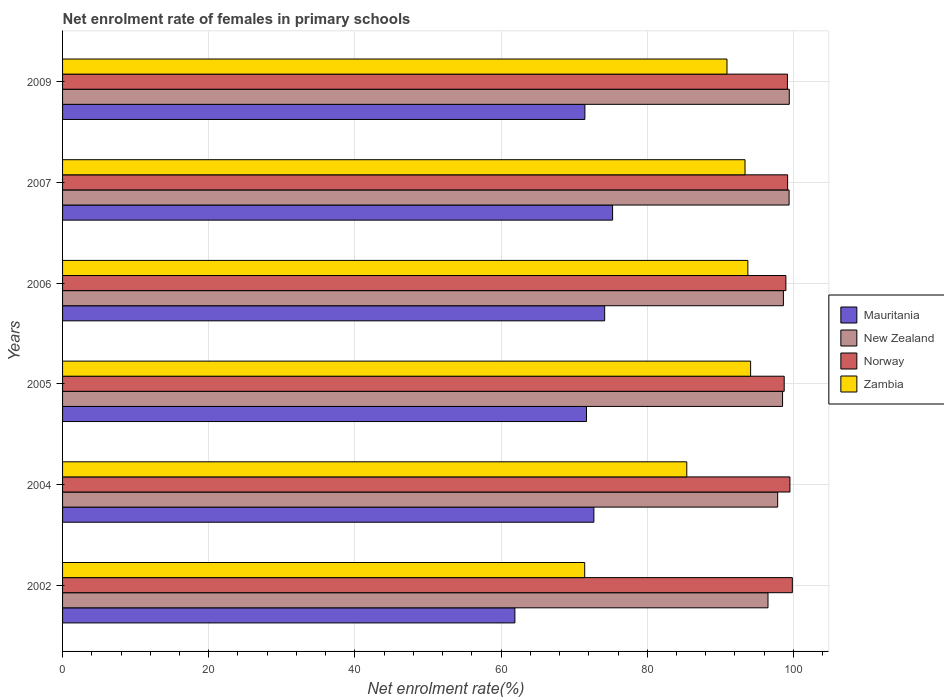How many different coloured bars are there?
Make the answer very short. 4. Are the number of bars per tick equal to the number of legend labels?
Ensure brevity in your answer.  Yes. Are the number of bars on each tick of the Y-axis equal?
Give a very brief answer. Yes. How many bars are there on the 4th tick from the top?
Keep it short and to the point. 4. How many bars are there on the 2nd tick from the bottom?
Provide a short and direct response. 4. What is the label of the 4th group of bars from the top?
Make the answer very short. 2005. What is the net enrolment rate of females in primary schools in Mauritania in 2007?
Provide a short and direct response. 75.26. Across all years, what is the maximum net enrolment rate of females in primary schools in New Zealand?
Offer a very short reply. 99.44. Across all years, what is the minimum net enrolment rate of females in primary schools in Mauritania?
Your answer should be very brief. 61.89. In which year was the net enrolment rate of females in primary schools in Norway minimum?
Make the answer very short. 2005. What is the total net enrolment rate of females in primary schools in Zambia in the graph?
Ensure brevity in your answer.  529.07. What is the difference between the net enrolment rate of females in primary schools in Norway in 2005 and that in 2006?
Make the answer very short. -0.23. What is the difference between the net enrolment rate of females in primary schools in Norway in 2005 and the net enrolment rate of females in primary schools in Mauritania in 2002?
Keep it short and to the point. 36.85. What is the average net enrolment rate of females in primary schools in Norway per year?
Your answer should be compact. 99.25. In the year 2002, what is the difference between the net enrolment rate of females in primary schools in Mauritania and net enrolment rate of females in primary schools in Norway?
Offer a terse response. -37.97. In how many years, is the net enrolment rate of females in primary schools in Zambia greater than 64 %?
Provide a succinct answer. 6. What is the ratio of the net enrolment rate of females in primary schools in New Zealand in 2002 to that in 2004?
Your answer should be very brief. 0.99. Is the net enrolment rate of females in primary schools in New Zealand in 2005 less than that in 2007?
Provide a succinct answer. Yes. What is the difference between the highest and the second highest net enrolment rate of females in primary schools in Norway?
Provide a short and direct response. 0.33. What is the difference between the highest and the lowest net enrolment rate of females in primary schools in New Zealand?
Ensure brevity in your answer.  2.91. Is the sum of the net enrolment rate of females in primary schools in New Zealand in 2004 and 2009 greater than the maximum net enrolment rate of females in primary schools in Mauritania across all years?
Your answer should be very brief. Yes. Is it the case that in every year, the sum of the net enrolment rate of females in primary schools in New Zealand and net enrolment rate of females in primary schools in Norway is greater than the sum of net enrolment rate of females in primary schools in Mauritania and net enrolment rate of females in primary schools in Zambia?
Your answer should be compact. No. What does the 4th bar from the top in 2009 represents?
Offer a very short reply. Mauritania. Is it the case that in every year, the sum of the net enrolment rate of females in primary schools in Mauritania and net enrolment rate of females in primary schools in New Zealand is greater than the net enrolment rate of females in primary schools in Norway?
Offer a terse response. Yes. How many bars are there?
Give a very brief answer. 24. Are all the bars in the graph horizontal?
Your answer should be compact. Yes. What is the difference between two consecutive major ticks on the X-axis?
Your response must be concise. 20. Are the values on the major ticks of X-axis written in scientific E-notation?
Make the answer very short. No. Does the graph contain any zero values?
Make the answer very short. No. Where does the legend appear in the graph?
Offer a very short reply. Center right. What is the title of the graph?
Give a very brief answer. Net enrolment rate of females in primary schools. What is the label or title of the X-axis?
Provide a succinct answer. Net enrolment rate(%). What is the Net enrolment rate(%) of Mauritania in 2002?
Provide a short and direct response. 61.89. What is the Net enrolment rate(%) of New Zealand in 2002?
Your answer should be compact. 96.52. What is the Net enrolment rate(%) of Norway in 2002?
Provide a succinct answer. 99.86. What is the Net enrolment rate(%) in Zambia in 2002?
Provide a short and direct response. 71.45. What is the Net enrolment rate(%) in Mauritania in 2004?
Provide a short and direct response. 72.7. What is the Net enrolment rate(%) of New Zealand in 2004?
Offer a terse response. 97.85. What is the Net enrolment rate(%) in Norway in 2004?
Ensure brevity in your answer.  99.52. What is the Net enrolment rate(%) of Zambia in 2004?
Your answer should be very brief. 85.41. What is the Net enrolment rate(%) in Mauritania in 2005?
Give a very brief answer. 71.69. What is the Net enrolment rate(%) in New Zealand in 2005?
Your answer should be very brief. 98.52. What is the Net enrolment rate(%) of Norway in 2005?
Offer a terse response. 98.74. What is the Net enrolment rate(%) of Zambia in 2005?
Your answer should be compact. 94.15. What is the Net enrolment rate(%) in Mauritania in 2006?
Your answer should be very brief. 74.18. What is the Net enrolment rate(%) in New Zealand in 2006?
Give a very brief answer. 98.63. What is the Net enrolment rate(%) in Norway in 2006?
Give a very brief answer. 98.97. What is the Net enrolment rate(%) in Zambia in 2006?
Keep it short and to the point. 93.77. What is the Net enrolment rate(%) in Mauritania in 2007?
Offer a very short reply. 75.26. What is the Net enrolment rate(%) in New Zealand in 2007?
Your answer should be compact. 99.41. What is the Net enrolment rate(%) in Norway in 2007?
Ensure brevity in your answer.  99.21. What is the Net enrolment rate(%) in Zambia in 2007?
Offer a terse response. 93.38. What is the Net enrolment rate(%) of Mauritania in 2009?
Your answer should be compact. 71.47. What is the Net enrolment rate(%) in New Zealand in 2009?
Offer a terse response. 99.44. What is the Net enrolment rate(%) of Norway in 2009?
Provide a short and direct response. 99.19. What is the Net enrolment rate(%) of Zambia in 2009?
Your answer should be compact. 90.91. Across all years, what is the maximum Net enrolment rate(%) in Mauritania?
Your answer should be compact. 75.26. Across all years, what is the maximum Net enrolment rate(%) in New Zealand?
Your answer should be compact. 99.44. Across all years, what is the maximum Net enrolment rate(%) of Norway?
Offer a very short reply. 99.86. Across all years, what is the maximum Net enrolment rate(%) in Zambia?
Your answer should be compact. 94.15. Across all years, what is the minimum Net enrolment rate(%) of Mauritania?
Make the answer very short. 61.89. Across all years, what is the minimum Net enrolment rate(%) in New Zealand?
Your answer should be compact. 96.52. Across all years, what is the minimum Net enrolment rate(%) of Norway?
Offer a very short reply. 98.74. Across all years, what is the minimum Net enrolment rate(%) of Zambia?
Your response must be concise. 71.45. What is the total Net enrolment rate(%) in Mauritania in the graph?
Offer a terse response. 427.19. What is the total Net enrolment rate(%) in New Zealand in the graph?
Offer a terse response. 590.38. What is the total Net enrolment rate(%) of Norway in the graph?
Keep it short and to the point. 595.49. What is the total Net enrolment rate(%) in Zambia in the graph?
Ensure brevity in your answer.  529.07. What is the difference between the Net enrolment rate(%) in Mauritania in 2002 and that in 2004?
Offer a terse response. -10.81. What is the difference between the Net enrolment rate(%) of New Zealand in 2002 and that in 2004?
Provide a short and direct response. -1.33. What is the difference between the Net enrolment rate(%) in Norway in 2002 and that in 2004?
Provide a short and direct response. 0.33. What is the difference between the Net enrolment rate(%) in Zambia in 2002 and that in 2004?
Provide a succinct answer. -13.97. What is the difference between the Net enrolment rate(%) of Mauritania in 2002 and that in 2005?
Ensure brevity in your answer.  -9.8. What is the difference between the Net enrolment rate(%) of New Zealand in 2002 and that in 2005?
Your response must be concise. -1.99. What is the difference between the Net enrolment rate(%) of Norway in 2002 and that in 2005?
Keep it short and to the point. 1.11. What is the difference between the Net enrolment rate(%) in Zambia in 2002 and that in 2005?
Make the answer very short. -22.7. What is the difference between the Net enrolment rate(%) in Mauritania in 2002 and that in 2006?
Your answer should be very brief. -12.28. What is the difference between the Net enrolment rate(%) in New Zealand in 2002 and that in 2006?
Ensure brevity in your answer.  -2.11. What is the difference between the Net enrolment rate(%) of Norway in 2002 and that in 2006?
Offer a terse response. 0.88. What is the difference between the Net enrolment rate(%) in Zambia in 2002 and that in 2006?
Your answer should be very brief. -22.32. What is the difference between the Net enrolment rate(%) in Mauritania in 2002 and that in 2007?
Offer a terse response. -13.37. What is the difference between the Net enrolment rate(%) in New Zealand in 2002 and that in 2007?
Give a very brief answer. -2.89. What is the difference between the Net enrolment rate(%) of Norway in 2002 and that in 2007?
Keep it short and to the point. 0.65. What is the difference between the Net enrolment rate(%) in Zambia in 2002 and that in 2007?
Your answer should be compact. -21.94. What is the difference between the Net enrolment rate(%) in Mauritania in 2002 and that in 2009?
Keep it short and to the point. -9.58. What is the difference between the Net enrolment rate(%) of New Zealand in 2002 and that in 2009?
Your answer should be compact. -2.91. What is the difference between the Net enrolment rate(%) of Norway in 2002 and that in 2009?
Your answer should be very brief. 0.67. What is the difference between the Net enrolment rate(%) of Zambia in 2002 and that in 2009?
Offer a terse response. -19.47. What is the difference between the Net enrolment rate(%) of Mauritania in 2004 and that in 2005?
Keep it short and to the point. 1.01. What is the difference between the Net enrolment rate(%) of New Zealand in 2004 and that in 2005?
Keep it short and to the point. -0.67. What is the difference between the Net enrolment rate(%) in Norway in 2004 and that in 2005?
Keep it short and to the point. 0.78. What is the difference between the Net enrolment rate(%) of Zambia in 2004 and that in 2005?
Your answer should be compact. -8.73. What is the difference between the Net enrolment rate(%) of Mauritania in 2004 and that in 2006?
Keep it short and to the point. -1.48. What is the difference between the Net enrolment rate(%) of New Zealand in 2004 and that in 2006?
Provide a short and direct response. -0.78. What is the difference between the Net enrolment rate(%) in Norway in 2004 and that in 2006?
Provide a succinct answer. 0.55. What is the difference between the Net enrolment rate(%) of Zambia in 2004 and that in 2006?
Your answer should be compact. -8.36. What is the difference between the Net enrolment rate(%) of Mauritania in 2004 and that in 2007?
Provide a succinct answer. -2.56. What is the difference between the Net enrolment rate(%) in New Zealand in 2004 and that in 2007?
Provide a short and direct response. -1.56. What is the difference between the Net enrolment rate(%) of Norway in 2004 and that in 2007?
Make the answer very short. 0.31. What is the difference between the Net enrolment rate(%) of Zambia in 2004 and that in 2007?
Your response must be concise. -7.97. What is the difference between the Net enrolment rate(%) of Mauritania in 2004 and that in 2009?
Provide a succinct answer. 1.23. What is the difference between the Net enrolment rate(%) in New Zealand in 2004 and that in 2009?
Make the answer very short. -1.59. What is the difference between the Net enrolment rate(%) of Norway in 2004 and that in 2009?
Provide a short and direct response. 0.34. What is the difference between the Net enrolment rate(%) of Zambia in 2004 and that in 2009?
Provide a succinct answer. -5.5. What is the difference between the Net enrolment rate(%) of Mauritania in 2005 and that in 2006?
Offer a terse response. -2.49. What is the difference between the Net enrolment rate(%) in New Zealand in 2005 and that in 2006?
Provide a succinct answer. -0.11. What is the difference between the Net enrolment rate(%) in Norway in 2005 and that in 2006?
Provide a succinct answer. -0.23. What is the difference between the Net enrolment rate(%) of Zambia in 2005 and that in 2006?
Your answer should be very brief. 0.38. What is the difference between the Net enrolment rate(%) of Mauritania in 2005 and that in 2007?
Your answer should be very brief. -3.57. What is the difference between the Net enrolment rate(%) in New Zealand in 2005 and that in 2007?
Provide a succinct answer. -0.89. What is the difference between the Net enrolment rate(%) in Norway in 2005 and that in 2007?
Provide a succinct answer. -0.47. What is the difference between the Net enrolment rate(%) of Zambia in 2005 and that in 2007?
Give a very brief answer. 0.77. What is the difference between the Net enrolment rate(%) in Mauritania in 2005 and that in 2009?
Your response must be concise. 0.22. What is the difference between the Net enrolment rate(%) of New Zealand in 2005 and that in 2009?
Make the answer very short. -0.92. What is the difference between the Net enrolment rate(%) of Norway in 2005 and that in 2009?
Keep it short and to the point. -0.44. What is the difference between the Net enrolment rate(%) of Zambia in 2005 and that in 2009?
Provide a succinct answer. 3.23. What is the difference between the Net enrolment rate(%) in Mauritania in 2006 and that in 2007?
Make the answer very short. -1.08. What is the difference between the Net enrolment rate(%) of New Zealand in 2006 and that in 2007?
Offer a terse response. -0.78. What is the difference between the Net enrolment rate(%) of Norway in 2006 and that in 2007?
Offer a terse response. -0.24. What is the difference between the Net enrolment rate(%) of Zambia in 2006 and that in 2007?
Ensure brevity in your answer.  0.39. What is the difference between the Net enrolment rate(%) in Mauritania in 2006 and that in 2009?
Provide a succinct answer. 2.71. What is the difference between the Net enrolment rate(%) of New Zealand in 2006 and that in 2009?
Make the answer very short. -0.81. What is the difference between the Net enrolment rate(%) in Norway in 2006 and that in 2009?
Offer a very short reply. -0.21. What is the difference between the Net enrolment rate(%) in Zambia in 2006 and that in 2009?
Your response must be concise. 2.86. What is the difference between the Net enrolment rate(%) of Mauritania in 2007 and that in 2009?
Make the answer very short. 3.79. What is the difference between the Net enrolment rate(%) of New Zealand in 2007 and that in 2009?
Make the answer very short. -0.03. What is the difference between the Net enrolment rate(%) of Norway in 2007 and that in 2009?
Provide a short and direct response. 0.02. What is the difference between the Net enrolment rate(%) in Zambia in 2007 and that in 2009?
Your answer should be very brief. 2.47. What is the difference between the Net enrolment rate(%) in Mauritania in 2002 and the Net enrolment rate(%) in New Zealand in 2004?
Give a very brief answer. -35.96. What is the difference between the Net enrolment rate(%) of Mauritania in 2002 and the Net enrolment rate(%) of Norway in 2004?
Your answer should be very brief. -37.63. What is the difference between the Net enrolment rate(%) in Mauritania in 2002 and the Net enrolment rate(%) in Zambia in 2004?
Your response must be concise. -23.52. What is the difference between the Net enrolment rate(%) of New Zealand in 2002 and the Net enrolment rate(%) of Norway in 2004?
Make the answer very short. -3. What is the difference between the Net enrolment rate(%) in New Zealand in 2002 and the Net enrolment rate(%) in Zambia in 2004?
Your answer should be compact. 11.11. What is the difference between the Net enrolment rate(%) in Norway in 2002 and the Net enrolment rate(%) in Zambia in 2004?
Make the answer very short. 14.45. What is the difference between the Net enrolment rate(%) in Mauritania in 2002 and the Net enrolment rate(%) in New Zealand in 2005?
Offer a very short reply. -36.63. What is the difference between the Net enrolment rate(%) in Mauritania in 2002 and the Net enrolment rate(%) in Norway in 2005?
Offer a very short reply. -36.85. What is the difference between the Net enrolment rate(%) in Mauritania in 2002 and the Net enrolment rate(%) in Zambia in 2005?
Offer a very short reply. -32.25. What is the difference between the Net enrolment rate(%) of New Zealand in 2002 and the Net enrolment rate(%) of Norway in 2005?
Give a very brief answer. -2.22. What is the difference between the Net enrolment rate(%) in New Zealand in 2002 and the Net enrolment rate(%) in Zambia in 2005?
Your answer should be compact. 2.38. What is the difference between the Net enrolment rate(%) of Norway in 2002 and the Net enrolment rate(%) of Zambia in 2005?
Offer a very short reply. 5.71. What is the difference between the Net enrolment rate(%) of Mauritania in 2002 and the Net enrolment rate(%) of New Zealand in 2006?
Make the answer very short. -36.74. What is the difference between the Net enrolment rate(%) of Mauritania in 2002 and the Net enrolment rate(%) of Norway in 2006?
Keep it short and to the point. -37.08. What is the difference between the Net enrolment rate(%) in Mauritania in 2002 and the Net enrolment rate(%) in Zambia in 2006?
Provide a short and direct response. -31.88. What is the difference between the Net enrolment rate(%) of New Zealand in 2002 and the Net enrolment rate(%) of Norway in 2006?
Make the answer very short. -2.45. What is the difference between the Net enrolment rate(%) in New Zealand in 2002 and the Net enrolment rate(%) in Zambia in 2006?
Your response must be concise. 2.75. What is the difference between the Net enrolment rate(%) of Norway in 2002 and the Net enrolment rate(%) of Zambia in 2006?
Keep it short and to the point. 6.09. What is the difference between the Net enrolment rate(%) of Mauritania in 2002 and the Net enrolment rate(%) of New Zealand in 2007?
Offer a very short reply. -37.52. What is the difference between the Net enrolment rate(%) of Mauritania in 2002 and the Net enrolment rate(%) of Norway in 2007?
Provide a succinct answer. -37.32. What is the difference between the Net enrolment rate(%) of Mauritania in 2002 and the Net enrolment rate(%) of Zambia in 2007?
Provide a succinct answer. -31.49. What is the difference between the Net enrolment rate(%) in New Zealand in 2002 and the Net enrolment rate(%) in Norway in 2007?
Your response must be concise. -2.69. What is the difference between the Net enrolment rate(%) in New Zealand in 2002 and the Net enrolment rate(%) in Zambia in 2007?
Offer a terse response. 3.14. What is the difference between the Net enrolment rate(%) of Norway in 2002 and the Net enrolment rate(%) of Zambia in 2007?
Keep it short and to the point. 6.48. What is the difference between the Net enrolment rate(%) of Mauritania in 2002 and the Net enrolment rate(%) of New Zealand in 2009?
Ensure brevity in your answer.  -37.55. What is the difference between the Net enrolment rate(%) in Mauritania in 2002 and the Net enrolment rate(%) in Norway in 2009?
Your answer should be compact. -37.3. What is the difference between the Net enrolment rate(%) in Mauritania in 2002 and the Net enrolment rate(%) in Zambia in 2009?
Your answer should be very brief. -29.02. What is the difference between the Net enrolment rate(%) in New Zealand in 2002 and the Net enrolment rate(%) in Norway in 2009?
Your response must be concise. -2.66. What is the difference between the Net enrolment rate(%) of New Zealand in 2002 and the Net enrolment rate(%) of Zambia in 2009?
Your response must be concise. 5.61. What is the difference between the Net enrolment rate(%) of Norway in 2002 and the Net enrolment rate(%) of Zambia in 2009?
Your answer should be very brief. 8.94. What is the difference between the Net enrolment rate(%) of Mauritania in 2004 and the Net enrolment rate(%) of New Zealand in 2005?
Offer a terse response. -25.82. What is the difference between the Net enrolment rate(%) in Mauritania in 2004 and the Net enrolment rate(%) in Norway in 2005?
Your answer should be very brief. -26.04. What is the difference between the Net enrolment rate(%) in Mauritania in 2004 and the Net enrolment rate(%) in Zambia in 2005?
Ensure brevity in your answer.  -21.45. What is the difference between the Net enrolment rate(%) of New Zealand in 2004 and the Net enrolment rate(%) of Norway in 2005?
Your response must be concise. -0.89. What is the difference between the Net enrolment rate(%) of New Zealand in 2004 and the Net enrolment rate(%) of Zambia in 2005?
Your answer should be very brief. 3.7. What is the difference between the Net enrolment rate(%) of Norway in 2004 and the Net enrolment rate(%) of Zambia in 2005?
Offer a terse response. 5.38. What is the difference between the Net enrolment rate(%) in Mauritania in 2004 and the Net enrolment rate(%) in New Zealand in 2006?
Ensure brevity in your answer.  -25.93. What is the difference between the Net enrolment rate(%) of Mauritania in 2004 and the Net enrolment rate(%) of Norway in 2006?
Offer a very short reply. -26.27. What is the difference between the Net enrolment rate(%) of Mauritania in 2004 and the Net enrolment rate(%) of Zambia in 2006?
Your answer should be very brief. -21.07. What is the difference between the Net enrolment rate(%) of New Zealand in 2004 and the Net enrolment rate(%) of Norway in 2006?
Keep it short and to the point. -1.12. What is the difference between the Net enrolment rate(%) of New Zealand in 2004 and the Net enrolment rate(%) of Zambia in 2006?
Offer a terse response. 4.08. What is the difference between the Net enrolment rate(%) in Norway in 2004 and the Net enrolment rate(%) in Zambia in 2006?
Your answer should be compact. 5.75. What is the difference between the Net enrolment rate(%) in Mauritania in 2004 and the Net enrolment rate(%) in New Zealand in 2007?
Make the answer very short. -26.71. What is the difference between the Net enrolment rate(%) of Mauritania in 2004 and the Net enrolment rate(%) of Norway in 2007?
Offer a very short reply. -26.51. What is the difference between the Net enrolment rate(%) in Mauritania in 2004 and the Net enrolment rate(%) in Zambia in 2007?
Keep it short and to the point. -20.68. What is the difference between the Net enrolment rate(%) in New Zealand in 2004 and the Net enrolment rate(%) in Norway in 2007?
Provide a short and direct response. -1.36. What is the difference between the Net enrolment rate(%) of New Zealand in 2004 and the Net enrolment rate(%) of Zambia in 2007?
Your answer should be very brief. 4.47. What is the difference between the Net enrolment rate(%) of Norway in 2004 and the Net enrolment rate(%) of Zambia in 2007?
Your answer should be compact. 6.14. What is the difference between the Net enrolment rate(%) in Mauritania in 2004 and the Net enrolment rate(%) in New Zealand in 2009?
Offer a terse response. -26.74. What is the difference between the Net enrolment rate(%) in Mauritania in 2004 and the Net enrolment rate(%) in Norway in 2009?
Provide a succinct answer. -26.49. What is the difference between the Net enrolment rate(%) of Mauritania in 2004 and the Net enrolment rate(%) of Zambia in 2009?
Ensure brevity in your answer.  -18.21. What is the difference between the Net enrolment rate(%) of New Zealand in 2004 and the Net enrolment rate(%) of Norway in 2009?
Offer a very short reply. -1.34. What is the difference between the Net enrolment rate(%) of New Zealand in 2004 and the Net enrolment rate(%) of Zambia in 2009?
Give a very brief answer. 6.94. What is the difference between the Net enrolment rate(%) in Norway in 2004 and the Net enrolment rate(%) in Zambia in 2009?
Make the answer very short. 8.61. What is the difference between the Net enrolment rate(%) in Mauritania in 2005 and the Net enrolment rate(%) in New Zealand in 2006?
Your answer should be very brief. -26.94. What is the difference between the Net enrolment rate(%) in Mauritania in 2005 and the Net enrolment rate(%) in Norway in 2006?
Offer a terse response. -27.28. What is the difference between the Net enrolment rate(%) in Mauritania in 2005 and the Net enrolment rate(%) in Zambia in 2006?
Provide a short and direct response. -22.08. What is the difference between the Net enrolment rate(%) of New Zealand in 2005 and the Net enrolment rate(%) of Norway in 2006?
Provide a succinct answer. -0.45. What is the difference between the Net enrolment rate(%) of New Zealand in 2005 and the Net enrolment rate(%) of Zambia in 2006?
Offer a terse response. 4.75. What is the difference between the Net enrolment rate(%) of Norway in 2005 and the Net enrolment rate(%) of Zambia in 2006?
Offer a very short reply. 4.97. What is the difference between the Net enrolment rate(%) in Mauritania in 2005 and the Net enrolment rate(%) in New Zealand in 2007?
Give a very brief answer. -27.72. What is the difference between the Net enrolment rate(%) of Mauritania in 2005 and the Net enrolment rate(%) of Norway in 2007?
Give a very brief answer. -27.52. What is the difference between the Net enrolment rate(%) of Mauritania in 2005 and the Net enrolment rate(%) of Zambia in 2007?
Offer a terse response. -21.69. What is the difference between the Net enrolment rate(%) in New Zealand in 2005 and the Net enrolment rate(%) in Norway in 2007?
Your response must be concise. -0.69. What is the difference between the Net enrolment rate(%) in New Zealand in 2005 and the Net enrolment rate(%) in Zambia in 2007?
Provide a succinct answer. 5.14. What is the difference between the Net enrolment rate(%) of Norway in 2005 and the Net enrolment rate(%) of Zambia in 2007?
Your response must be concise. 5.36. What is the difference between the Net enrolment rate(%) of Mauritania in 2005 and the Net enrolment rate(%) of New Zealand in 2009?
Keep it short and to the point. -27.75. What is the difference between the Net enrolment rate(%) of Mauritania in 2005 and the Net enrolment rate(%) of Norway in 2009?
Offer a very short reply. -27.5. What is the difference between the Net enrolment rate(%) in Mauritania in 2005 and the Net enrolment rate(%) in Zambia in 2009?
Ensure brevity in your answer.  -19.22. What is the difference between the Net enrolment rate(%) of New Zealand in 2005 and the Net enrolment rate(%) of Norway in 2009?
Give a very brief answer. -0.67. What is the difference between the Net enrolment rate(%) of New Zealand in 2005 and the Net enrolment rate(%) of Zambia in 2009?
Your response must be concise. 7.61. What is the difference between the Net enrolment rate(%) of Norway in 2005 and the Net enrolment rate(%) of Zambia in 2009?
Keep it short and to the point. 7.83. What is the difference between the Net enrolment rate(%) of Mauritania in 2006 and the Net enrolment rate(%) of New Zealand in 2007?
Ensure brevity in your answer.  -25.24. What is the difference between the Net enrolment rate(%) in Mauritania in 2006 and the Net enrolment rate(%) in Norway in 2007?
Ensure brevity in your answer.  -25.03. What is the difference between the Net enrolment rate(%) in Mauritania in 2006 and the Net enrolment rate(%) in Zambia in 2007?
Give a very brief answer. -19.2. What is the difference between the Net enrolment rate(%) of New Zealand in 2006 and the Net enrolment rate(%) of Norway in 2007?
Offer a terse response. -0.58. What is the difference between the Net enrolment rate(%) in New Zealand in 2006 and the Net enrolment rate(%) in Zambia in 2007?
Offer a terse response. 5.25. What is the difference between the Net enrolment rate(%) in Norway in 2006 and the Net enrolment rate(%) in Zambia in 2007?
Keep it short and to the point. 5.59. What is the difference between the Net enrolment rate(%) in Mauritania in 2006 and the Net enrolment rate(%) in New Zealand in 2009?
Provide a short and direct response. -25.26. What is the difference between the Net enrolment rate(%) of Mauritania in 2006 and the Net enrolment rate(%) of Norway in 2009?
Ensure brevity in your answer.  -25.01. What is the difference between the Net enrolment rate(%) of Mauritania in 2006 and the Net enrolment rate(%) of Zambia in 2009?
Make the answer very short. -16.74. What is the difference between the Net enrolment rate(%) of New Zealand in 2006 and the Net enrolment rate(%) of Norway in 2009?
Provide a succinct answer. -0.55. What is the difference between the Net enrolment rate(%) of New Zealand in 2006 and the Net enrolment rate(%) of Zambia in 2009?
Ensure brevity in your answer.  7.72. What is the difference between the Net enrolment rate(%) in Norway in 2006 and the Net enrolment rate(%) in Zambia in 2009?
Your response must be concise. 8.06. What is the difference between the Net enrolment rate(%) in Mauritania in 2007 and the Net enrolment rate(%) in New Zealand in 2009?
Provide a succinct answer. -24.18. What is the difference between the Net enrolment rate(%) in Mauritania in 2007 and the Net enrolment rate(%) in Norway in 2009?
Offer a terse response. -23.93. What is the difference between the Net enrolment rate(%) in Mauritania in 2007 and the Net enrolment rate(%) in Zambia in 2009?
Offer a terse response. -15.65. What is the difference between the Net enrolment rate(%) of New Zealand in 2007 and the Net enrolment rate(%) of Norway in 2009?
Your response must be concise. 0.23. What is the difference between the Net enrolment rate(%) of New Zealand in 2007 and the Net enrolment rate(%) of Zambia in 2009?
Provide a short and direct response. 8.5. What is the difference between the Net enrolment rate(%) in Norway in 2007 and the Net enrolment rate(%) in Zambia in 2009?
Make the answer very short. 8.3. What is the average Net enrolment rate(%) of Mauritania per year?
Your answer should be very brief. 71.2. What is the average Net enrolment rate(%) of New Zealand per year?
Give a very brief answer. 98.4. What is the average Net enrolment rate(%) of Norway per year?
Provide a short and direct response. 99.25. What is the average Net enrolment rate(%) of Zambia per year?
Your answer should be compact. 88.18. In the year 2002, what is the difference between the Net enrolment rate(%) in Mauritania and Net enrolment rate(%) in New Zealand?
Your answer should be compact. -34.63. In the year 2002, what is the difference between the Net enrolment rate(%) of Mauritania and Net enrolment rate(%) of Norway?
Offer a very short reply. -37.97. In the year 2002, what is the difference between the Net enrolment rate(%) of Mauritania and Net enrolment rate(%) of Zambia?
Your response must be concise. -9.55. In the year 2002, what is the difference between the Net enrolment rate(%) in New Zealand and Net enrolment rate(%) in Norway?
Provide a short and direct response. -3.33. In the year 2002, what is the difference between the Net enrolment rate(%) of New Zealand and Net enrolment rate(%) of Zambia?
Offer a terse response. 25.08. In the year 2002, what is the difference between the Net enrolment rate(%) of Norway and Net enrolment rate(%) of Zambia?
Your response must be concise. 28.41. In the year 2004, what is the difference between the Net enrolment rate(%) in Mauritania and Net enrolment rate(%) in New Zealand?
Offer a terse response. -25.15. In the year 2004, what is the difference between the Net enrolment rate(%) in Mauritania and Net enrolment rate(%) in Norway?
Give a very brief answer. -26.83. In the year 2004, what is the difference between the Net enrolment rate(%) of Mauritania and Net enrolment rate(%) of Zambia?
Make the answer very short. -12.71. In the year 2004, what is the difference between the Net enrolment rate(%) of New Zealand and Net enrolment rate(%) of Norway?
Offer a terse response. -1.67. In the year 2004, what is the difference between the Net enrolment rate(%) of New Zealand and Net enrolment rate(%) of Zambia?
Your response must be concise. 12.44. In the year 2004, what is the difference between the Net enrolment rate(%) of Norway and Net enrolment rate(%) of Zambia?
Provide a succinct answer. 14.11. In the year 2005, what is the difference between the Net enrolment rate(%) of Mauritania and Net enrolment rate(%) of New Zealand?
Your answer should be compact. -26.83. In the year 2005, what is the difference between the Net enrolment rate(%) of Mauritania and Net enrolment rate(%) of Norway?
Provide a short and direct response. -27.05. In the year 2005, what is the difference between the Net enrolment rate(%) in Mauritania and Net enrolment rate(%) in Zambia?
Your answer should be very brief. -22.46. In the year 2005, what is the difference between the Net enrolment rate(%) in New Zealand and Net enrolment rate(%) in Norway?
Make the answer very short. -0.22. In the year 2005, what is the difference between the Net enrolment rate(%) of New Zealand and Net enrolment rate(%) of Zambia?
Provide a succinct answer. 4.37. In the year 2005, what is the difference between the Net enrolment rate(%) of Norway and Net enrolment rate(%) of Zambia?
Offer a terse response. 4.6. In the year 2006, what is the difference between the Net enrolment rate(%) in Mauritania and Net enrolment rate(%) in New Zealand?
Provide a succinct answer. -24.46. In the year 2006, what is the difference between the Net enrolment rate(%) of Mauritania and Net enrolment rate(%) of Norway?
Your answer should be very brief. -24.8. In the year 2006, what is the difference between the Net enrolment rate(%) of Mauritania and Net enrolment rate(%) of Zambia?
Offer a very short reply. -19.59. In the year 2006, what is the difference between the Net enrolment rate(%) in New Zealand and Net enrolment rate(%) in Norway?
Make the answer very short. -0.34. In the year 2006, what is the difference between the Net enrolment rate(%) of New Zealand and Net enrolment rate(%) of Zambia?
Your answer should be very brief. 4.86. In the year 2006, what is the difference between the Net enrolment rate(%) in Norway and Net enrolment rate(%) in Zambia?
Offer a very short reply. 5.2. In the year 2007, what is the difference between the Net enrolment rate(%) in Mauritania and Net enrolment rate(%) in New Zealand?
Offer a terse response. -24.15. In the year 2007, what is the difference between the Net enrolment rate(%) of Mauritania and Net enrolment rate(%) of Norway?
Offer a very short reply. -23.95. In the year 2007, what is the difference between the Net enrolment rate(%) of Mauritania and Net enrolment rate(%) of Zambia?
Offer a very short reply. -18.12. In the year 2007, what is the difference between the Net enrolment rate(%) of New Zealand and Net enrolment rate(%) of Norway?
Offer a very short reply. 0.2. In the year 2007, what is the difference between the Net enrolment rate(%) of New Zealand and Net enrolment rate(%) of Zambia?
Provide a succinct answer. 6.03. In the year 2007, what is the difference between the Net enrolment rate(%) in Norway and Net enrolment rate(%) in Zambia?
Your answer should be compact. 5.83. In the year 2009, what is the difference between the Net enrolment rate(%) in Mauritania and Net enrolment rate(%) in New Zealand?
Offer a very short reply. -27.97. In the year 2009, what is the difference between the Net enrolment rate(%) of Mauritania and Net enrolment rate(%) of Norway?
Provide a succinct answer. -27.72. In the year 2009, what is the difference between the Net enrolment rate(%) of Mauritania and Net enrolment rate(%) of Zambia?
Ensure brevity in your answer.  -19.44. In the year 2009, what is the difference between the Net enrolment rate(%) in New Zealand and Net enrolment rate(%) in Norway?
Offer a very short reply. 0.25. In the year 2009, what is the difference between the Net enrolment rate(%) in New Zealand and Net enrolment rate(%) in Zambia?
Your answer should be very brief. 8.52. In the year 2009, what is the difference between the Net enrolment rate(%) of Norway and Net enrolment rate(%) of Zambia?
Your answer should be very brief. 8.27. What is the ratio of the Net enrolment rate(%) in Mauritania in 2002 to that in 2004?
Ensure brevity in your answer.  0.85. What is the ratio of the Net enrolment rate(%) of New Zealand in 2002 to that in 2004?
Your answer should be compact. 0.99. What is the ratio of the Net enrolment rate(%) in Norway in 2002 to that in 2004?
Provide a succinct answer. 1. What is the ratio of the Net enrolment rate(%) in Zambia in 2002 to that in 2004?
Your response must be concise. 0.84. What is the ratio of the Net enrolment rate(%) of Mauritania in 2002 to that in 2005?
Ensure brevity in your answer.  0.86. What is the ratio of the Net enrolment rate(%) of New Zealand in 2002 to that in 2005?
Ensure brevity in your answer.  0.98. What is the ratio of the Net enrolment rate(%) of Norway in 2002 to that in 2005?
Your answer should be very brief. 1.01. What is the ratio of the Net enrolment rate(%) of Zambia in 2002 to that in 2005?
Give a very brief answer. 0.76. What is the ratio of the Net enrolment rate(%) in Mauritania in 2002 to that in 2006?
Provide a short and direct response. 0.83. What is the ratio of the Net enrolment rate(%) of New Zealand in 2002 to that in 2006?
Provide a short and direct response. 0.98. What is the ratio of the Net enrolment rate(%) in Norway in 2002 to that in 2006?
Make the answer very short. 1.01. What is the ratio of the Net enrolment rate(%) of Zambia in 2002 to that in 2006?
Ensure brevity in your answer.  0.76. What is the ratio of the Net enrolment rate(%) in Mauritania in 2002 to that in 2007?
Ensure brevity in your answer.  0.82. What is the ratio of the Net enrolment rate(%) in New Zealand in 2002 to that in 2007?
Make the answer very short. 0.97. What is the ratio of the Net enrolment rate(%) in Zambia in 2002 to that in 2007?
Provide a short and direct response. 0.77. What is the ratio of the Net enrolment rate(%) of Mauritania in 2002 to that in 2009?
Your answer should be compact. 0.87. What is the ratio of the Net enrolment rate(%) of New Zealand in 2002 to that in 2009?
Your answer should be very brief. 0.97. What is the ratio of the Net enrolment rate(%) in Norway in 2002 to that in 2009?
Ensure brevity in your answer.  1.01. What is the ratio of the Net enrolment rate(%) in Zambia in 2002 to that in 2009?
Offer a terse response. 0.79. What is the ratio of the Net enrolment rate(%) of Mauritania in 2004 to that in 2005?
Provide a short and direct response. 1.01. What is the ratio of the Net enrolment rate(%) in New Zealand in 2004 to that in 2005?
Offer a very short reply. 0.99. What is the ratio of the Net enrolment rate(%) in Norway in 2004 to that in 2005?
Provide a short and direct response. 1.01. What is the ratio of the Net enrolment rate(%) in Zambia in 2004 to that in 2005?
Your answer should be compact. 0.91. What is the ratio of the Net enrolment rate(%) in Mauritania in 2004 to that in 2006?
Offer a terse response. 0.98. What is the ratio of the Net enrolment rate(%) in Norway in 2004 to that in 2006?
Your response must be concise. 1.01. What is the ratio of the Net enrolment rate(%) in Zambia in 2004 to that in 2006?
Provide a succinct answer. 0.91. What is the ratio of the Net enrolment rate(%) in New Zealand in 2004 to that in 2007?
Provide a succinct answer. 0.98. What is the ratio of the Net enrolment rate(%) in Zambia in 2004 to that in 2007?
Provide a short and direct response. 0.91. What is the ratio of the Net enrolment rate(%) in Mauritania in 2004 to that in 2009?
Your response must be concise. 1.02. What is the ratio of the Net enrolment rate(%) of New Zealand in 2004 to that in 2009?
Your answer should be compact. 0.98. What is the ratio of the Net enrolment rate(%) in Zambia in 2004 to that in 2009?
Your response must be concise. 0.94. What is the ratio of the Net enrolment rate(%) in Mauritania in 2005 to that in 2006?
Your answer should be very brief. 0.97. What is the ratio of the Net enrolment rate(%) in New Zealand in 2005 to that in 2006?
Give a very brief answer. 1. What is the ratio of the Net enrolment rate(%) of Mauritania in 2005 to that in 2007?
Provide a short and direct response. 0.95. What is the ratio of the Net enrolment rate(%) of Zambia in 2005 to that in 2007?
Your response must be concise. 1.01. What is the ratio of the Net enrolment rate(%) of Zambia in 2005 to that in 2009?
Ensure brevity in your answer.  1.04. What is the ratio of the Net enrolment rate(%) of Mauritania in 2006 to that in 2007?
Your answer should be compact. 0.99. What is the ratio of the Net enrolment rate(%) in Mauritania in 2006 to that in 2009?
Offer a terse response. 1.04. What is the ratio of the Net enrolment rate(%) of New Zealand in 2006 to that in 2009?
Keep it short and to the point. 0.99. What is the ratio of the Net enrolment rate(%) of Norway in 2006 to that in 2009?
Keep it short and to the point. 1. What is the ratio of the Net enrolment rate(%) in Zambia in 2006 to that in 2009?
Keep it short and to the point. 1.03. What is the ratio of the Net enrolment rate(%) in Mauritania in 2007 to that in 2009?
Provide a short and direct response. 1.05. What is the ratio of the Net enrolment rate(%) of Zambia in 2007 to that in 2009?
Provide a short and direct response. 1.03. What is the difference between the highest and the second highest Net enrolment rate(%) in Mauritania?
Ensure brevity in your answer.  1.08. What is the difference between the highest and the second highest Net enrolment rate(%) of New Zealand?
Give a very brief answer. 0.03. What is the difference between the highest and the second highest Net enrolment rate(%) in Norway?
Offer a very short reply. 0.33. What is the difference between the highest and the second highest Net enrolment rate(%) in Zambia?
Your answer should be compact. 0.38. What is the difference between the highest and the lowest Net enrolment rate(%) of Mauritania?
Provide a short and direct response. 13.37. What is the difference between the highest and the lowest Net enrolment rate(%) in New Zealand?
Provide a short and direct response. 2.91. What is the difference between the highest and the lowest Net enrolment rate(%) in Norway?
Make the answer very short. 1.11. What is the difference between the highest and the lowest Net enrolment rate(%) of Zambia?
Your answer should be very brief. 22.7. 